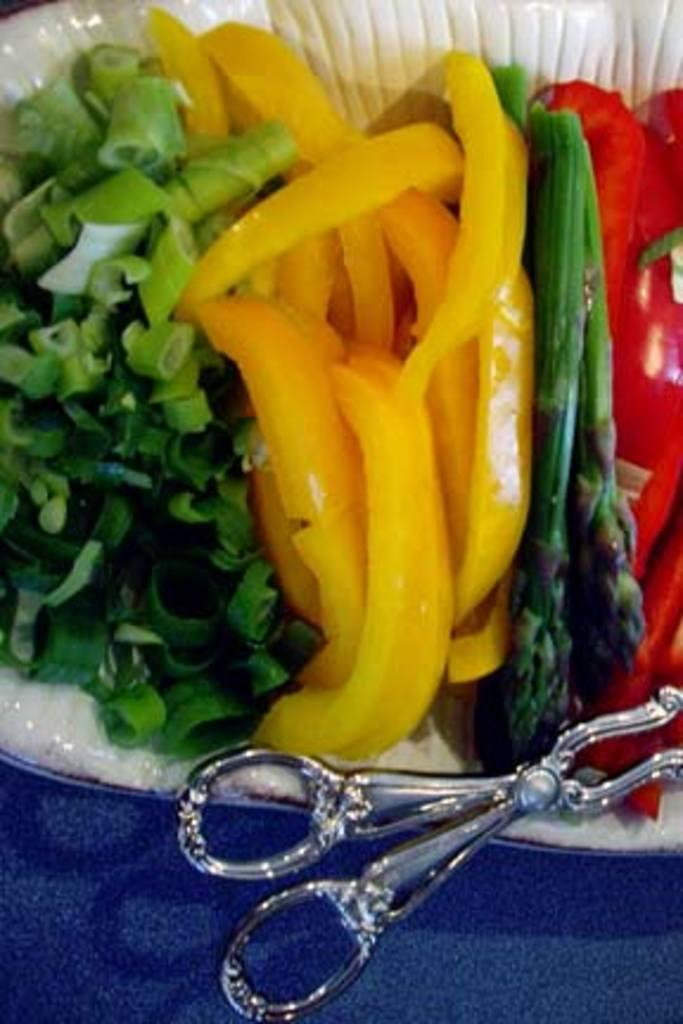What is the color of the surface at the bottom of the image? There is a colored surface at the bottom of the image, but the specific color is not mentioned. What is in the bowl that is visible in the image? There is food in a bowl in the image. What material is the bowl made of? The bowl appears to be made of metal. Who is the manager of the restaurant in the image? There is no indication of a restaurant or a manager in the image. How does the porter stop the food from spilling in the image? There is no porter or food spilling in the image. 